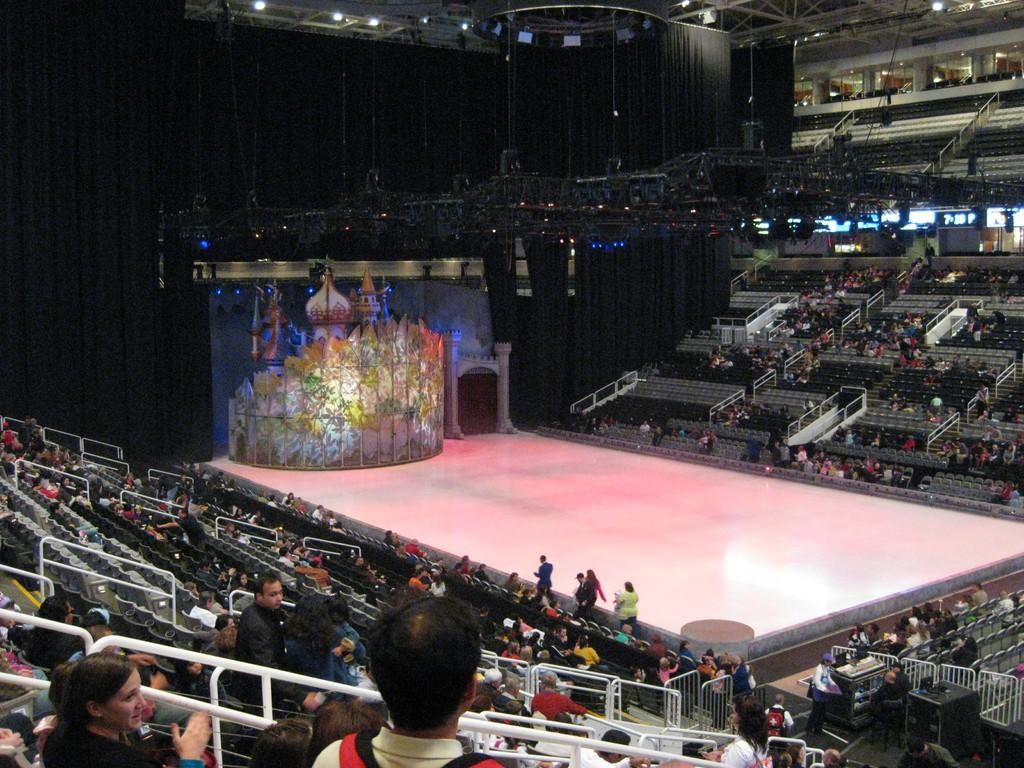How many people are in the image? The number of people in the image cannot be determined from the provided facts. What are some people doing in the image? Some people are standing, and some are sitting on chairs. What is the main feature of the image? There is a stage in the image. What can be seen in the background of the image? There are lights visible in the background. What type of net is being used by the people on the stage in the image? There is no net present in the image; it features people standing or sitting on chairs near a stage with lights visible in the background. 